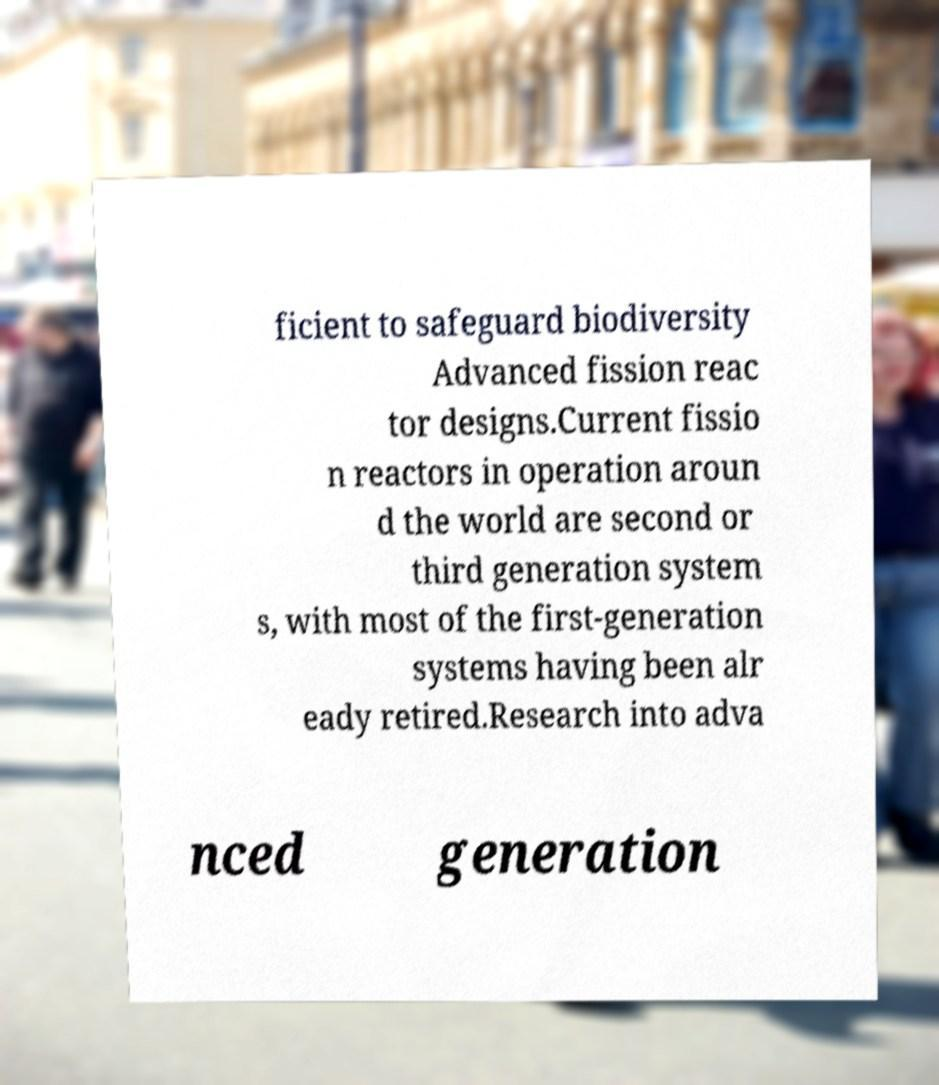What messages or text are displayed in this image? I need them in a readable, typed format. ficient to safeguard biodiversity Advanced fission reac tor designs.Current fissio n reactors in operation aroun d the world are second or third generation system s, with most of the first-generation systems having been alr eady retired.Research into adva nced generation 